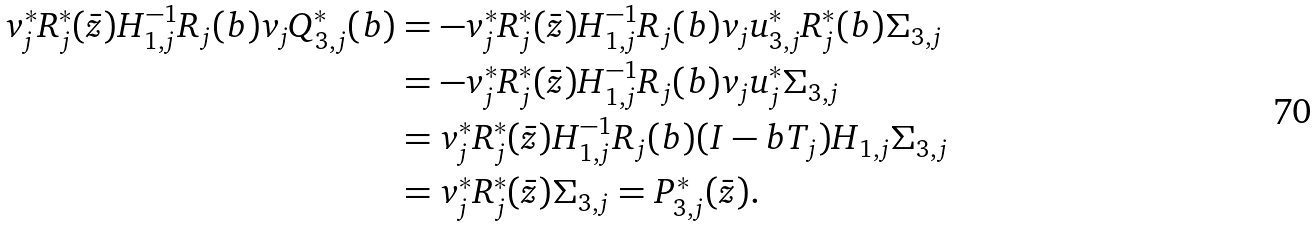Convert formula to latex. <formula><loc_0><loc_0><loc_500><loc_500>v _ { j } ^ { * } R _ { j } ^ { * } ( \bar { z } ) H _ { 1 , j } ^ { - 1 } R _ { j } ( b ) v _ { j } Q _ { 3 , j } ^ { * } ( b ) & = - v _ { j } ^ { * } R _ { j } ^ { * } ( \bar { z } ) H _ { 1 , j } ^ { - 1 } R _ { j } ( b ) v _ { j } u _ { 3 , j } ^ { * } R _ { j } ^ { * } ( b ) \Sigma _ { 3 , j } \\ & = - v _ { j } ^ { * } R _ { j } ^ { * } ( \bar { z } ) H _ { 1 , j } ^ { - 1 } R _ { j } ( b ) v _ { j } u _ { j } ^ { * } \Sigma _ { 3 , j } \\ & = v _ { j } ^ { * } R _ { j } ^ { * } ( \bar { z } ) H _ { 1 , j } ^ { - 1 } R _ { j } ( b ) ( I - b T _ { j } ) H _ { 1 , j } \Sigma _ { 3 , j } \\ & = v _ { j } ^ { * } R _ { j } ^ { * } ( \bar { z } ) \Sigma _ { 3 , j } = P _ { 3 , j } ^ { * } ( \bar { z } ) .</formula> 